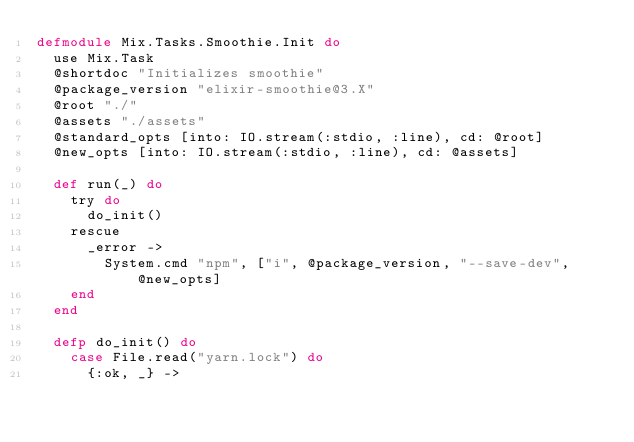Convert code to text. <code><loc_0><loc_0><loc_500><loc_500><_Elixir_>defmodule Mix.Tasks.Smoothie.Init do
  use Mix.Task
  @shortdoc "Initializes smoothie"
  @package_version "elixir-smoothie@3.X"
  @root "./"
  @assets "./assets"
  @standard_opts [into: IO.stream(:stdio, :line), cd: @root]
  @new_opts [into: IO.stream(:stdio, :line), cd: @assets]

  def run(_) do
    try do
      do_init()
    rescue
      _error ->
        System.cmd "npm", ["i", @package_version, "--save-dev", @new_opts]
    end
  end

  defp do_init() do
    case File.read("yarn.lock") do
      {:ok, _} -></code> 